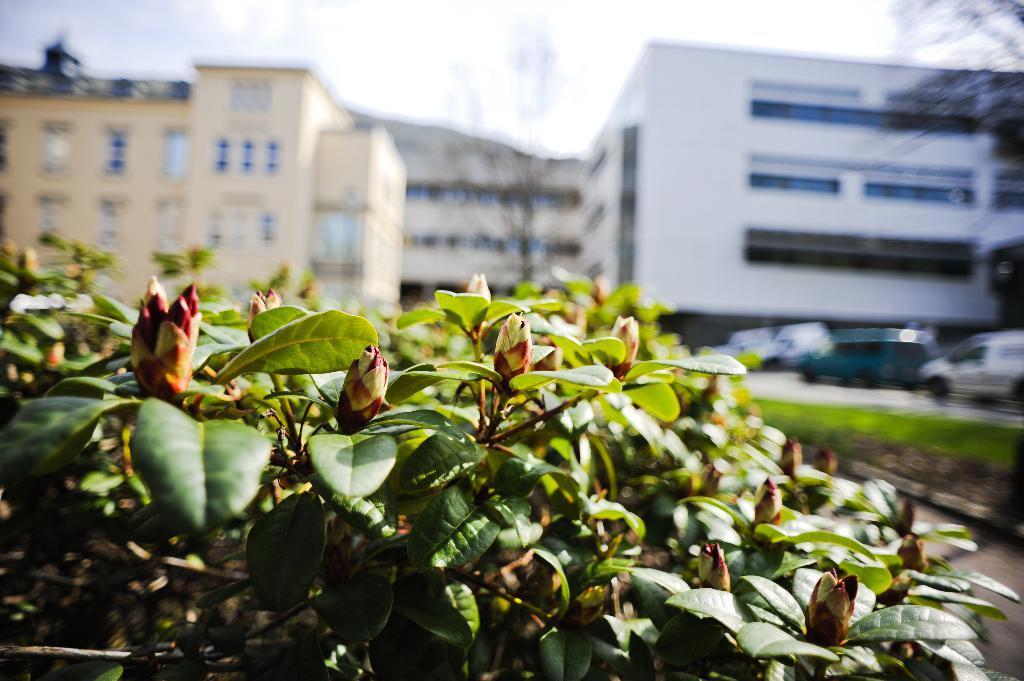Describe this image in one or two sentences. In this image I see the plants over here and I see that totally blurred in the background and I see the buildings and few vehicles over here and I see the sky and I see the grass over here. 